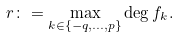<formula> <loc_0><loc_0><loc_500><loc_500>r \colon = \max _ { k \in \{ - q , \dots , p \} } \deg f _ { k } .</formula> 